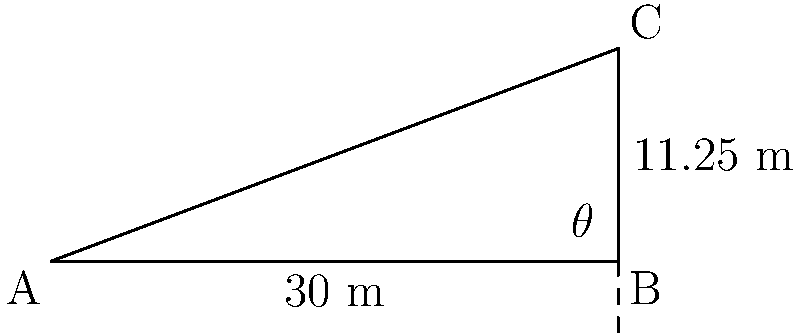On a trek through the Khangai Mountains, you come across a slope that you want to measure. Using a rangefinder, you determine that the horizontal distance to a point on the slope is 30 meters, and its vertical height is 11.25 meters. What is the angle of inclination ($\theta$) of the mountain slope? To find the angle of inclination, we can use the tangent trigonometric function. Here's how:

1) In a right triangle, tangent of an angle is the ratio of the opposite side to the adjacent side.

2) In this case:
   - The vertical height (opposite side) is 11.25 meters
   - The horizontal distance (adjacent side) is 30 meters

3) We can set up the equation:

   $$\tan(\theta) = \frac{\text{opposite}}{\text{adjacent}} = \frac{11.25}{30}$$

4) To find $\theta$, we need to take the inverse tangent (arctan or $\tan^{-1}$) of both sides:

   $$\theta = \tan^{-1}(\frac{11.25}{30})$$

5) Using a calculator or computer:

   $$\theta \approx 20.556^\circ$$

6) Rounding to the nearest degree:

   $$\theta \approx 21^\circ$$

Thus, the angle of inclination of the mountain slope is approximately 21 degrees.
Answer: $21^\circ$ 